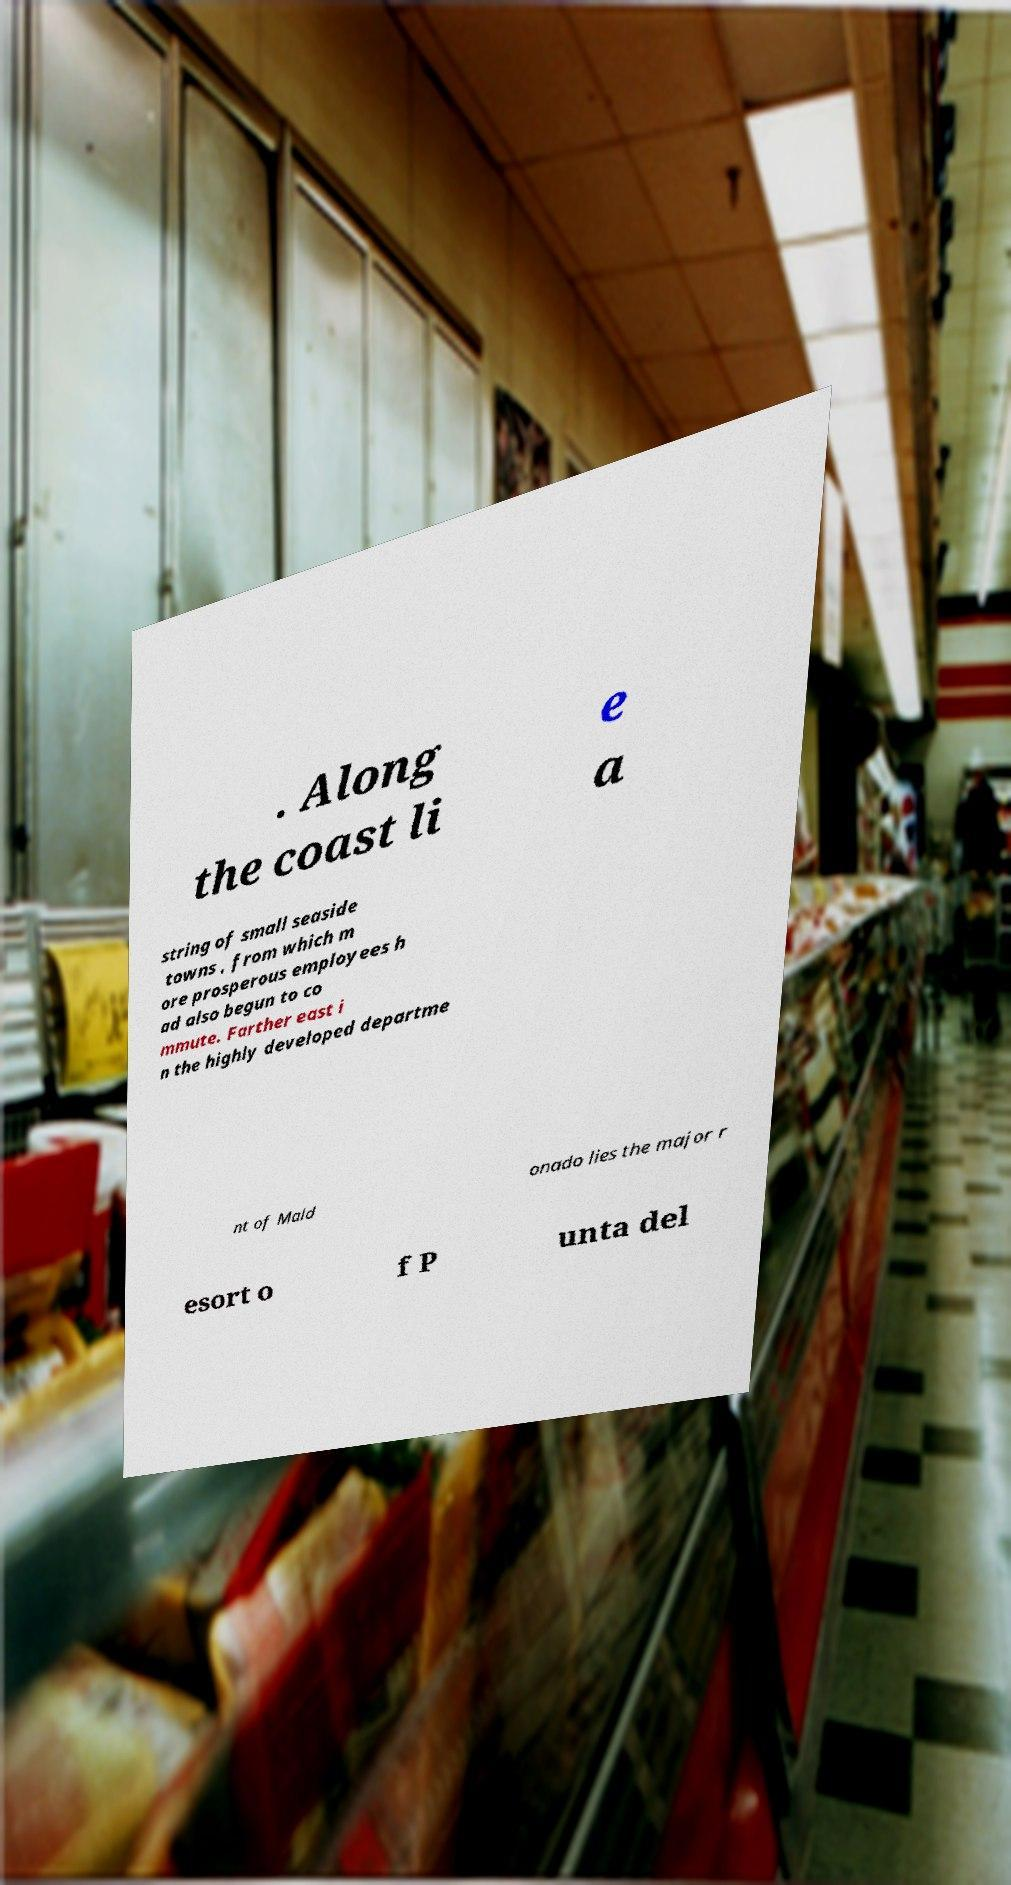Could you assist in decoding the text presented in this image and type it out clearly? . Along the coast li e a string of small seaside towns , from which m ore prosperous employees h ad also begun to co mmute. Farther east i n the highly developed departme nt of Mald onado lies the major r esort o f P unta del 